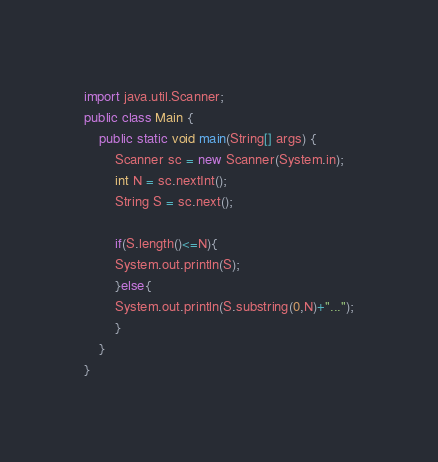<code> <loc_0><loc_0><loc_500><loc_500><_Java_>import java.util.Scanner;
public class Main {
	public static void main(String[] args) {
		Scanner sc = new Scanner(System.in);
		int N = sc.nextInt();
        String S = sc.next();
        
        if(S.length()<=N){
        System.out.println(S);
        }else{
        System.out.println(S.substring(0,N)+"...");
        }
	}
}</code> 